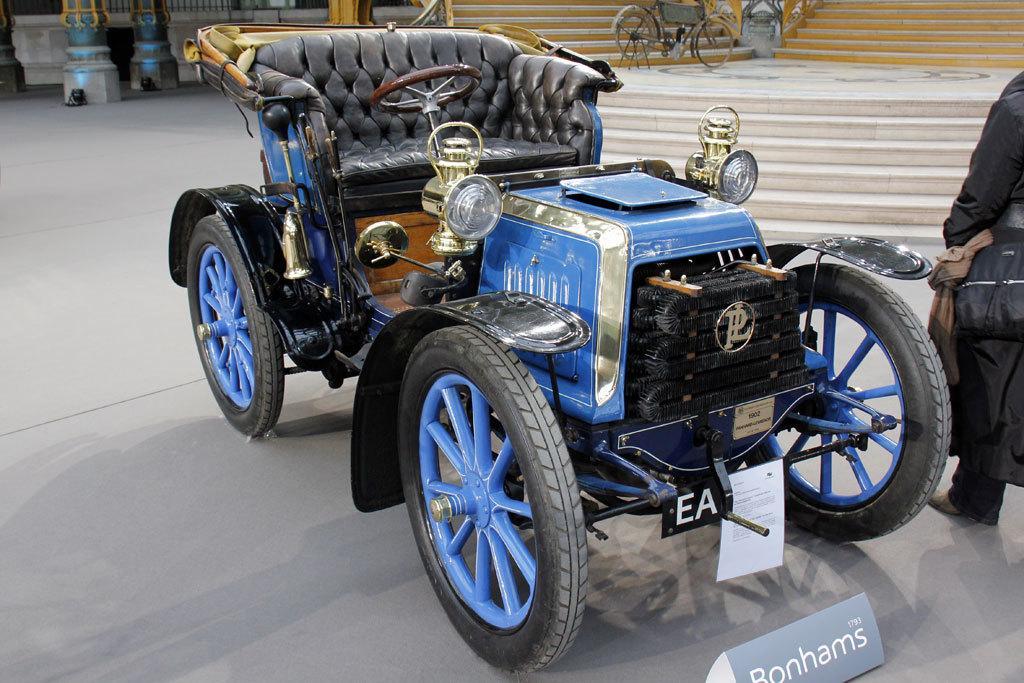Please provide a concise description of this image. In this image we can see a vehicle which is in blue color and there is a person standing beside the vehicle and we can see a bicycle in the background. 